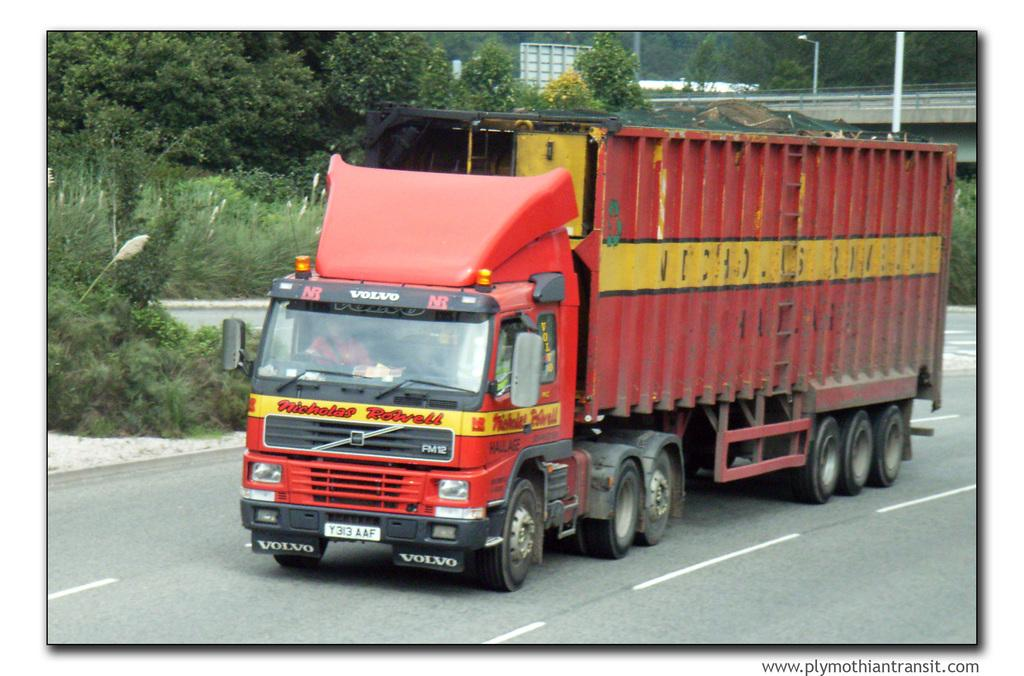What is on the road in the image? There is a vehicle on the road in the image. What can be seen in the background of the image? In the background of the image, there are planets, a bridge, light poles, trees, and some unspecified objects. Can you describe the bridge in the image? The bridge is located in the background of the image. What type of objects are present in the background of the image? The background of the image contains planets, a bridge, light poles, trees, and some unspecified objects. What year is depicted in the image? The image does not depict a specific year; it is a photograph of a scene that could be from any time. Can you see a tiger in the image? No, there is no tiger present in the image. 